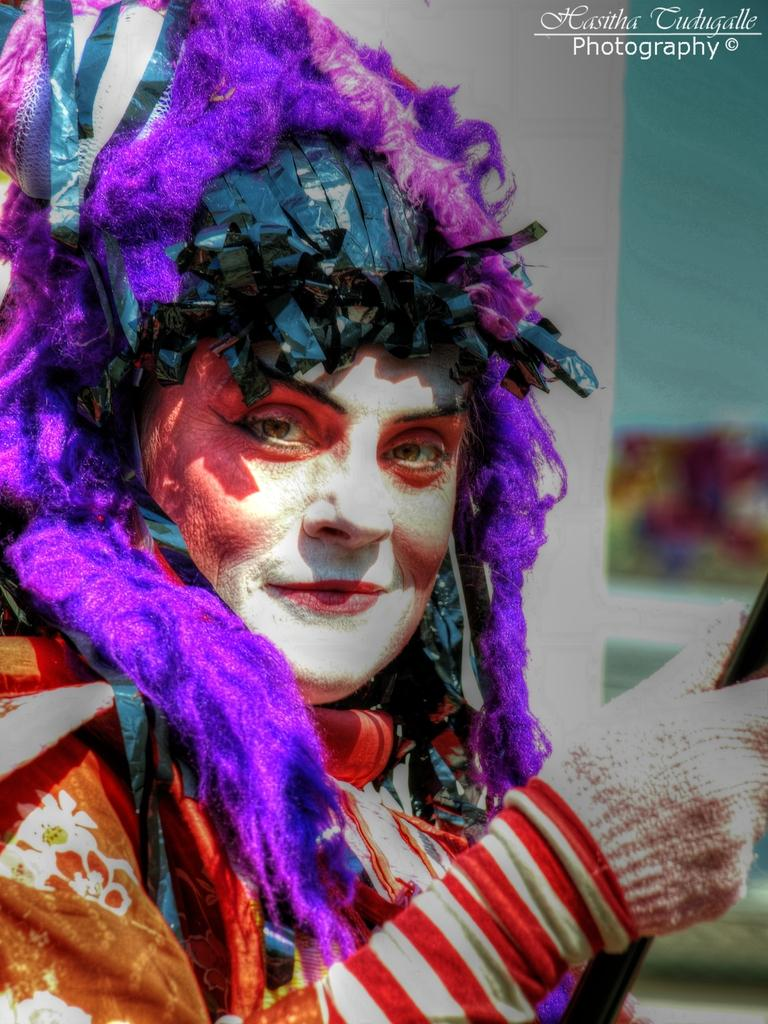Who or what is present in the image? There is a person in the image. What is the person doing or expressing? The person is smiling. How is the person dressed? The person is wearing a fancy dress. What can be observed about the background of the image? The background of the image is blurred. Is there any additional information or marking on the image? There is a watermark on the image. What type of pollution can be seen in the image? There is no pollution visible in the image; it features a person smiling and wearing a fancy dress. What kind of badge is the person wearing in the image? There is no badge visible in the image; the person is wearing a fancy dress. 